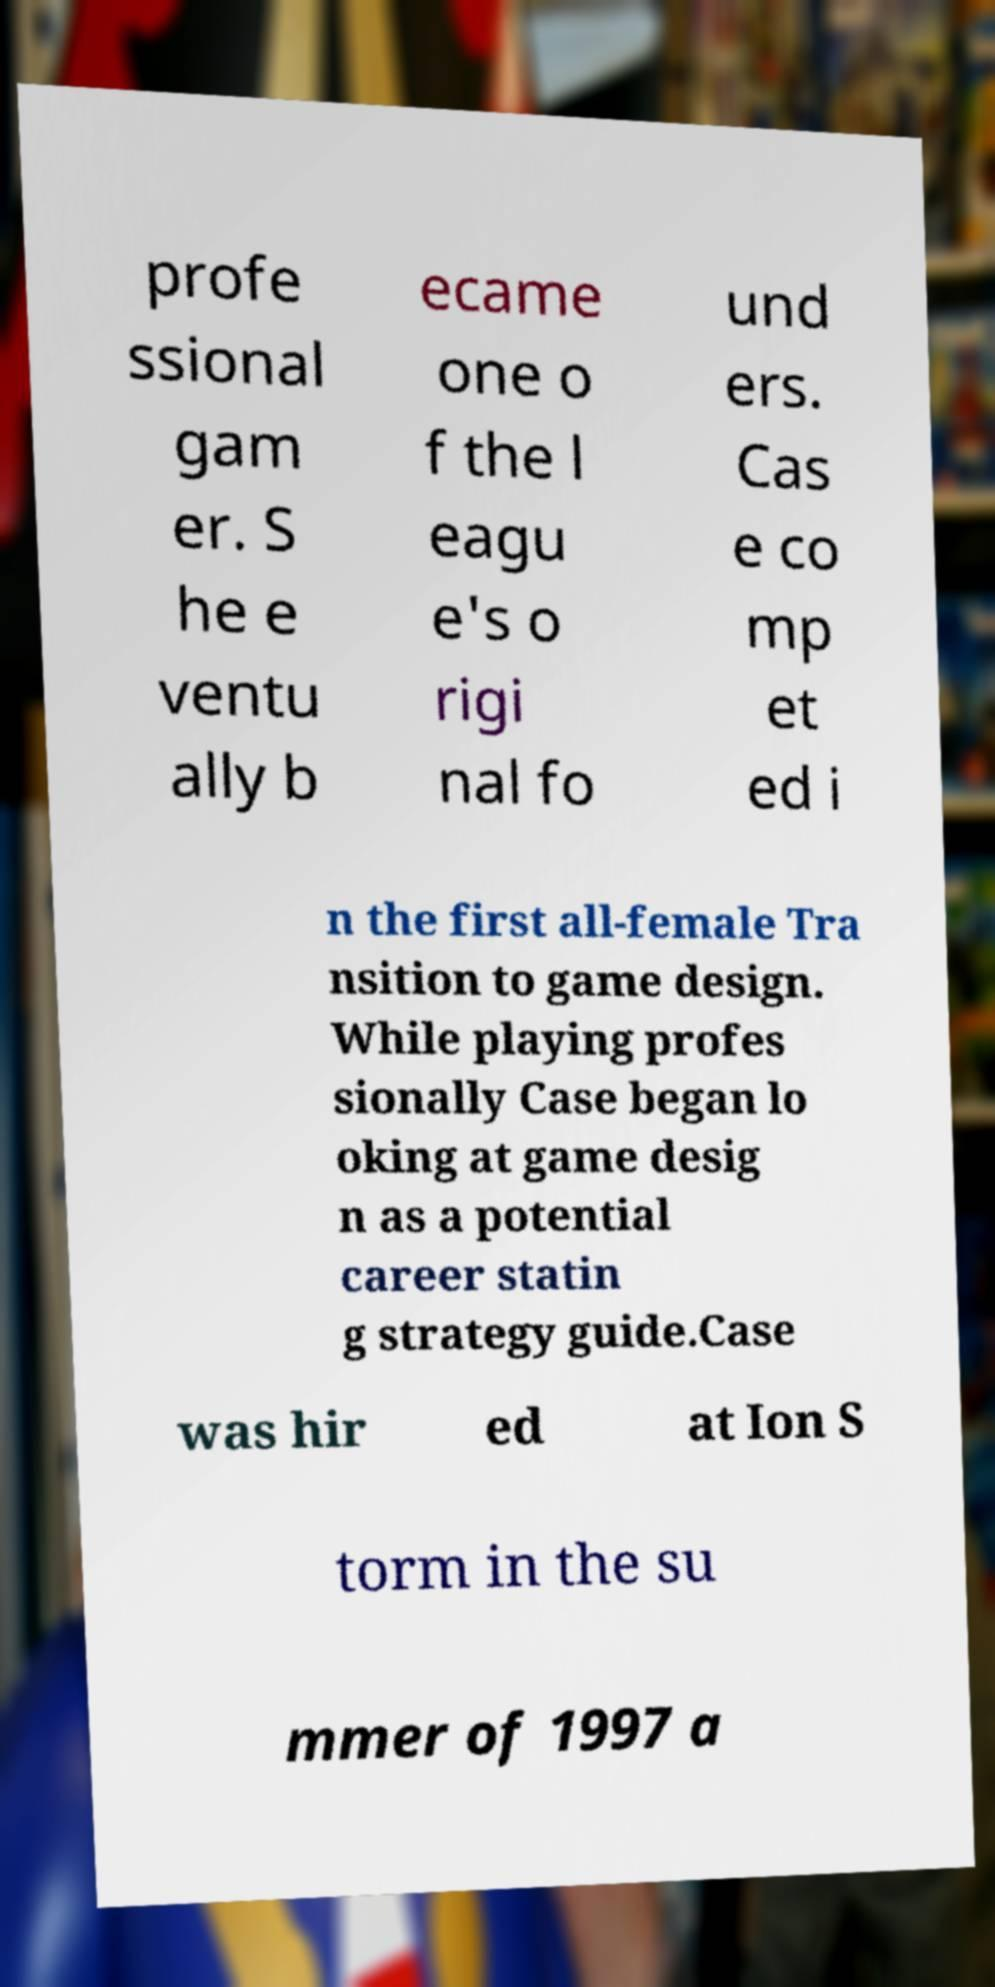For documentation purposes, I need the text within this image transcribed. Could you provide that? profe ssional gam er. S he e ventu ally b ecame one o f the l eagu e's o rigi nal fo und ers. Cas e co mp et ed i n the first all-female Tra nsition to game design. While playing profes sionally Case began lo oking at game desig n as a potential career statin g strategy guide.Case was hir ed at Ion S torm in the su mmer of 1997 a 